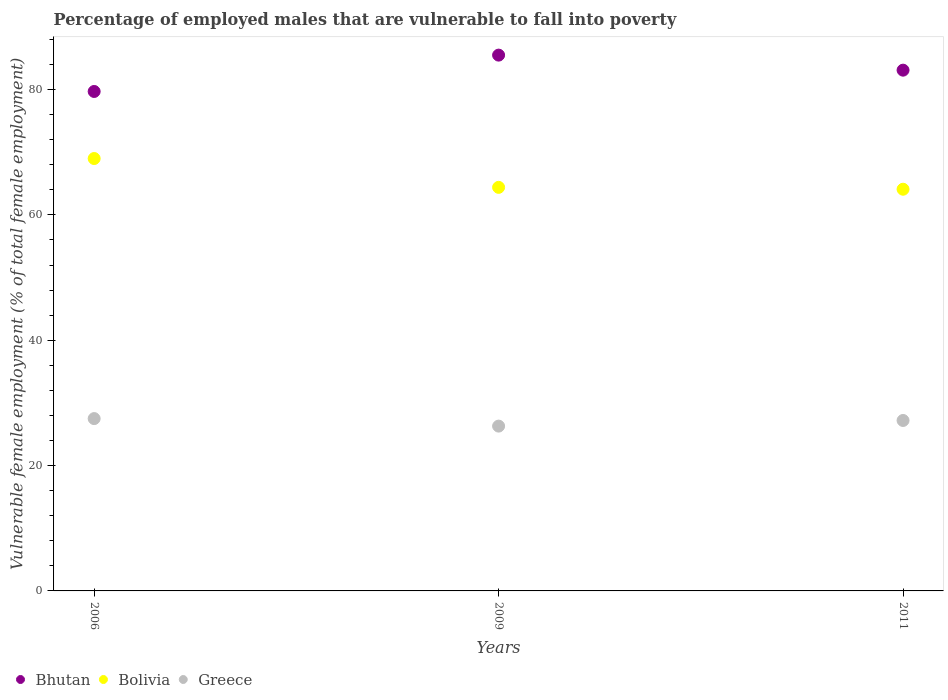Is the number of dotlines equal to the number of legend labels?
Provide a short and direct response. Yes. What is the percentage of employed males who are vulnerable to fall into poverty in Bhutan in 2011?
Keep it short and to the point. 83.1. Across all years, what is the maximum percentage of employed males who are vulnerable to fall into poverty in Bolivia?
Ensure brevity in your answer.  69. Across all years, what is the minimum percentage of employed males who are vulnerable to fall into poverty in Bolivia?
Ensure brevity in your answer.  64.1. What is the total percentage of employed males who are vulnerable to fall into poverty in Bolivia in the graph?
Offer a terse response. 197.5. What is the difference between the percentage of employed males who are vulnerable to fall into poverty in Bolivia in 2009 and that in 2011?
Keep it short and to the point. 0.3. What is the difference between the percentage of employed males who are vulnerable to fall into poverty in Bolivia in 2006 and the percentage of employed males who are vulnerable to fall into poverty in Greece in 2011?
Give a very brief answer. 41.8. What is the average percentage of employed males who are vulnerable to fall into poverty in Bhutan per year?
Keep it short and to the point. 82.77. In the year 2006, what is the difference between the percentage of employed males who are vulnerable to fall into poverty in Bolivia and percentage of employed males who are vulnerable to fall into poverty in Bhutan?
Offer a terse response. -10.7. What is the ratio of the percentage of employed males who are vulnerable to fall into poverty in Greece in 2009 to that in 2011?
Offer a terse response. 0.97. Is the difference between the percentage of employed males who are vulnerable to fall into poverty in Bolivia in 2009 and 2011 greater than the difference between the percentage of employed males who are vulnerable to fall into poverty in Bhutan in 2009 and 2011?
Make the answer very short. No. What is the difference between the highest and the second highest percentage of employed males who are vulnerable to fall into poverty in Bhutan?
Ensure brevity in your answer.  2.4. What is the difference between the highest and the lowest percentage of employed males who are vulnerable to fall into poverty in Greece?
Offer a very short reply. 1.2. In how many years, is the percentage of employed males who are vulnerable to fall into poverty in Bolivia greater than the average percentage of employed males who are vulnerable to fall into poverty in Bolivia taken over all years?
Your response must be concise. 1. Is it the case that in every year, the sum of the percentage of employed males who are vulnerable to fall into poverty in Bolivia and percentage of employed males who are vulnerable to fall into poverty in Bhutan  is greater than the percentage of employed males who are vulnerable to fall into poverty in Greece?
Ensure brevity in your answer.  Yes. Is the percentage of employed males who are vulnerable to fall into poverty in Bolivia strictly less than the percentage of employed males who are vulnerable to fall into poverty in Greece over the years?
Offer a very short reply. No. How many years are there in the graph?
Ensure brevity in your answer.  3. Does the graph contain grids?
Offer a very short reply. No. Where does the legend appear in the graph?
Provide a short and direct response. Bottom left. How many legend labels are there?
Ensure brevity in your answer.  3. How are the legend labels stacked?
Keep it short and to the point. Horizontal. What is the title of the graph?
Your response must be concise. Percentage of employed males that are vulnerable to fall into poverty. Does "Cabo Verde" appear as one of the legend labels in the graph?
Your response must be concise. No. What is the label or title of the Y-axis?
Your response must be concise. Vulnerable female employment (% of total female employment). What is the Vulnerable female employment (% of total female employment) in Bhutan in 2006?
Give a very brief answer. 79.7. What is the Vulnerable female employment (% of total female employment) in Bhutan in 2009?
Ensure brevity in your answer.  85.5. What is the Vulnerable female employment (% of total female employment) in Bolivia in 2009?
Offer a very short reply. 64.4. What is the Vulnerable female employment (% of total female employment) of Greece in 2009?
Your answer should be very brief. 26.3. What is the Vulnerable female employment (% of total female employment) in Bhutan in 2011?
Your answer should be compact. 83.1. What is the Vulnerable female employment (% of total female employment) in Bolivia in 2011?
Ensure brevity in your answer.  64.1. What is the Vulnerable female employment (% of total female employment) in Greece in 2011?
Offer a very short reply. 27.2. Across all years, what is the maximum Vulnerable female employment (% of total female employment) of Bhutan?
Keep it short and to the point. 85.5. Across all years, what is the maximum Vulnerable female employment (% of total female employment) of Bolivia?
Ensure brevity in your answer.  69. Across all years, what is the maximum Vulnerable female employment (% of total female employment) of Greece?
Keep it short and to the point. 27.5. Across all years, what is the minimum Vulnerable female employment (% of total female employment) in Bhutan?
Make the answer very short. 79.7. Across all years, what is the minimum Vulnerable female employment (% of total female employment) of Bolivia?
Offer a terse response. 64.1. Across all years, what is the minimum Vulnerable female employment (% of total female employment) in Greece?
Your answer should be compact. 26.3. What is the total Vulnerable female employment (% of total female employment) of Bhutan in the graph?
Offer a very short reply. 248.3. What is the total Vulnerable female employment (% of total female employment) in Bolivia in the graph?
Provide a short and direct response. 197.5. What is the total Vulnerable female employment (% of total female employment) of Greece in the graph?
Your response must be concise. 81. What is the difference between the Vulnerable female employment (% of total female employment) of Bhutan in 2006 and that in 2009?
Provide a succinct answer. -5.8. What is the difference between the Vulnerable female employment (% of total female employment) of Bolivia in 2006 and that in 2009?
Your answer should be very brief. 4.6. What is the difference between the Vulnerable female employment (% of total female employment) of Greece in 2006 and that in 2011?
Offer a terse response. 0.3. What is the difference between the Vulnerable female employment (% of total female employment) in Bhutan in 2009 and that in 2011?
Provide a short and direct response. 2.4. What is the difference between the Vulnerable female employment (% of total female employment) in Greece in 2009 and that in 2011?
Your answer should be compact. -0.9. What is the difference between the Vulnerable female employment (% of total female employment) of Bhutan in 2006 and the Vulnerable female employment (% of total female employment) of Bolivia in 2009?
Provide a short and direct response. 15.3. What is the difference between the Vulnerable female employment (% of total female employment) of Bhutan in 2006 and the Vulnerable female employment (% of total female employment) of Greece in 2009?
Ensure brevity in your answer.  53.4. What is the difference between the Vulnerable female employment (% of total female employment) in Bolivia in 2006 and the Vulnerable female employment (% of total female employment) in Greece in 2009?
Keep it short and to the point. 42.7. What is the difference between the Vulnerable female employment (% of total female employment) in Bhutan in 2006 and the Vulnerable female employment (% of total female employment) in Bolivia in 2011?
Provide a succinct answer. 15.6. What is the difference between the Vulnerable female employment (% of total female employment) of Bhutan in 2006 and the Vulnerable female employment (% of total female employment) of Greece in 2011?
Make the answer very short. 52.5. What is the difference between the Vulnerable female employment (% of total female employment) of Bolivia in 2006 and the Vulnerable female employment (% of total female employment) of Greece in 2011?
Offer a terse response. 41.8. What is the difference between the Vulnerable female employment (% of total female employment) in Bhutan in 2009 and the Vulnerable female employment (% of total female employment) in Bolivia in 2011?
Offer a very short reply. 21.4. What is the difference between the Vulnerable female employment (% of total female employment) of Bhutan in 2009 and the Vulnerable female employment (% of total female employment) of Greece in 2011?
Your answer should be very brief. 58.3. What is the difference between the Vulnerable female employment (% of total female employment) of Bolivia in 2009 and the Vulnerable female employment (% of total female employment) of Greece in 2011?
Your response must be concise. 37.2. What is the average Vulnerable female employment (% of total female employment) of Bhutan per year?
Provide a succinct answer. 82.77. What is the average Vulnerable female employment (% of total female employment) of Bolivia per year?
Offer a very short reply. 65.83. What is the average Vulnerable female employment (% of total female employment) in Greece per year?
Your response must be concise. 27. In the year 2006, what is the difference between the Vulnerable female employment (% of total female employment) of Bhutan and Vulnerable female employment (% of total female employment) of Bolivia?
Your response must be concise. 10.7. In the year 2006, what is the difference between the Vulnerable female employment (% of total female employment) in Bhutan and Vulnerable female employment (% of total female employment) in Greece?
Offer a very short reply. 52.2. In the year 2006, what is the difference between the Vulnerable female employment (% of total female employment) in Bolivia and Vulnerable female employment (% of total female employment) in Greece?
Your response must be concise. 41.5. In the year 2009, what is the difference between the Vulnerable female employment (% of total female employment) in Bhutan and Vulnerable female employment (% of total female employment) in Bolivia?
Your answer should be very brief. 21.1. In the year 2009, what is the difference between the Vulnerable female employment (% of total female employment) in Bhutan and Vulnerable female employment (% of total female employment) in Greece?
Offer a terse response. 59.2. In the year 2009, what is the difference between the Vulnerable female employment (% of total female employment) of Bolivia and Vulnerable female employment (% of total female employment) of Greece?
Provide a short and direct response. 38.1. In the year 2011, what is the difference between the Vulnerable female employment (% of total female employment) in Bhutan and Vulnerable female employment (% of total female employment) in Greece?
Offer a very short reply. 55.9. In the year 2011, what is the difference between the Vulnerable female employment (% of total female employment) in Bolivia and Vulnerable female employment (% of total female employment) in Greece?
Your answer should be very brief. 36.9. What is the ratio of the Vulnerable female employment (% of total female employment) of Bhutan in 2006 to that in 2009?
Keep it short and to the point. 0.93. What is the ratio of the Vulnerable female employment (% of total female employment) of Bolivia in 2006 to that in 2009?
Your response must be concise. 1.07. What is the ratio of the Vulnerable female employment (% of total female employment) of Greece in 2006 to that in 2009?
Your answer should be very brief. 1.05. What is the ratio of the Vulnerable female employment (% of total female employment) of Bhutan in 2006 to that in 2011?
Provide a succinct answer. 0.96. What is the ratio of the Vulnerable female employment (% of total female employment) in Bolivia in 2006 to that in 2011?
Keep it short and to the point. 1.08. What is the ratio of the Vulnerable female employment (% of total female employment) of Greece in 2006 to that in 2011?
Make the answer very short. 1.01. What is the ratio of the Vulnerable female employment (% of total female employment) of Bhutan in 2009 to that in 2011?
Your response must be concise. 1.03. What is the ratio of the Vulnerable female employment (% of total female employment) of Greece in 2009 to that in 2011?
Ensure brevity in your answer.  0.97. What is the difference between the highest and the second highest Vulnerable female employment (% of total female employment) in Bhutan?
Offer a very short reply. 2.4. What is the difference between the highest and the second highest Vulnerable female employment (% of total female employment) of Greece?
Make the answer very short. 0.3. What is the difference between the highest and the lowest Vulnerable female employment (% of total female employment) of Bhutan?
Your answer should be very brief. 5.8. What is the difference between the highest and the lowest Vulnerable female employment (% of total female employment) in Bolivia?
Give a very brief answer. 4.9. What is the difference between the highest and the lowest Vulnerable female employment (% of total female employment) of Greece?
Your answer should be very brief. 1.2. 